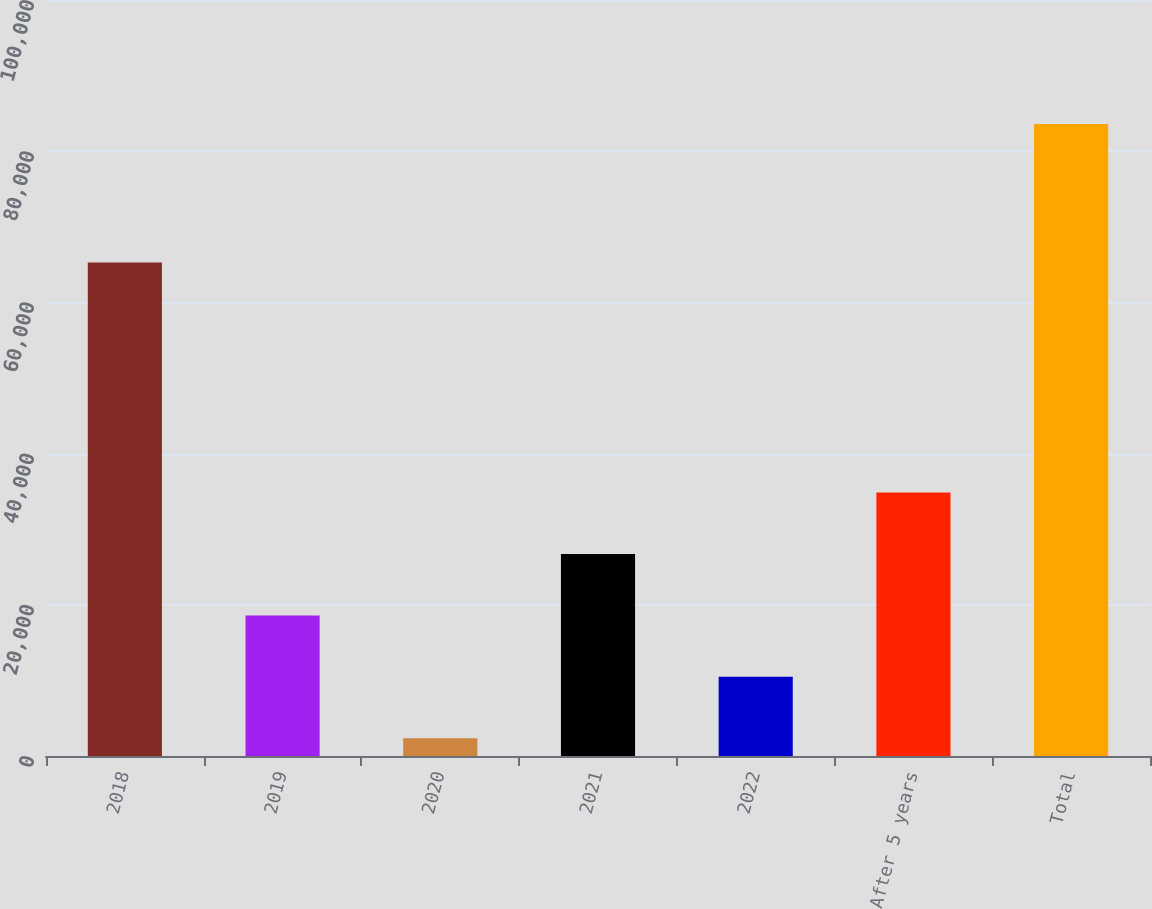Convert chart. <chart><loc_0><loc_0><loc_500><loc_500><bar_chart><fcel>2018<fcel>2019<fcel>2020<fcel>2021<fcel>2022<fcel>After 5 years<fcel>Total<nl><fcel>65266<fcel>18600.2<fcel>2354<fcel>26723.3<fcel>10477.1<fcel>34846.4<fcel>83585<nl></chart> 